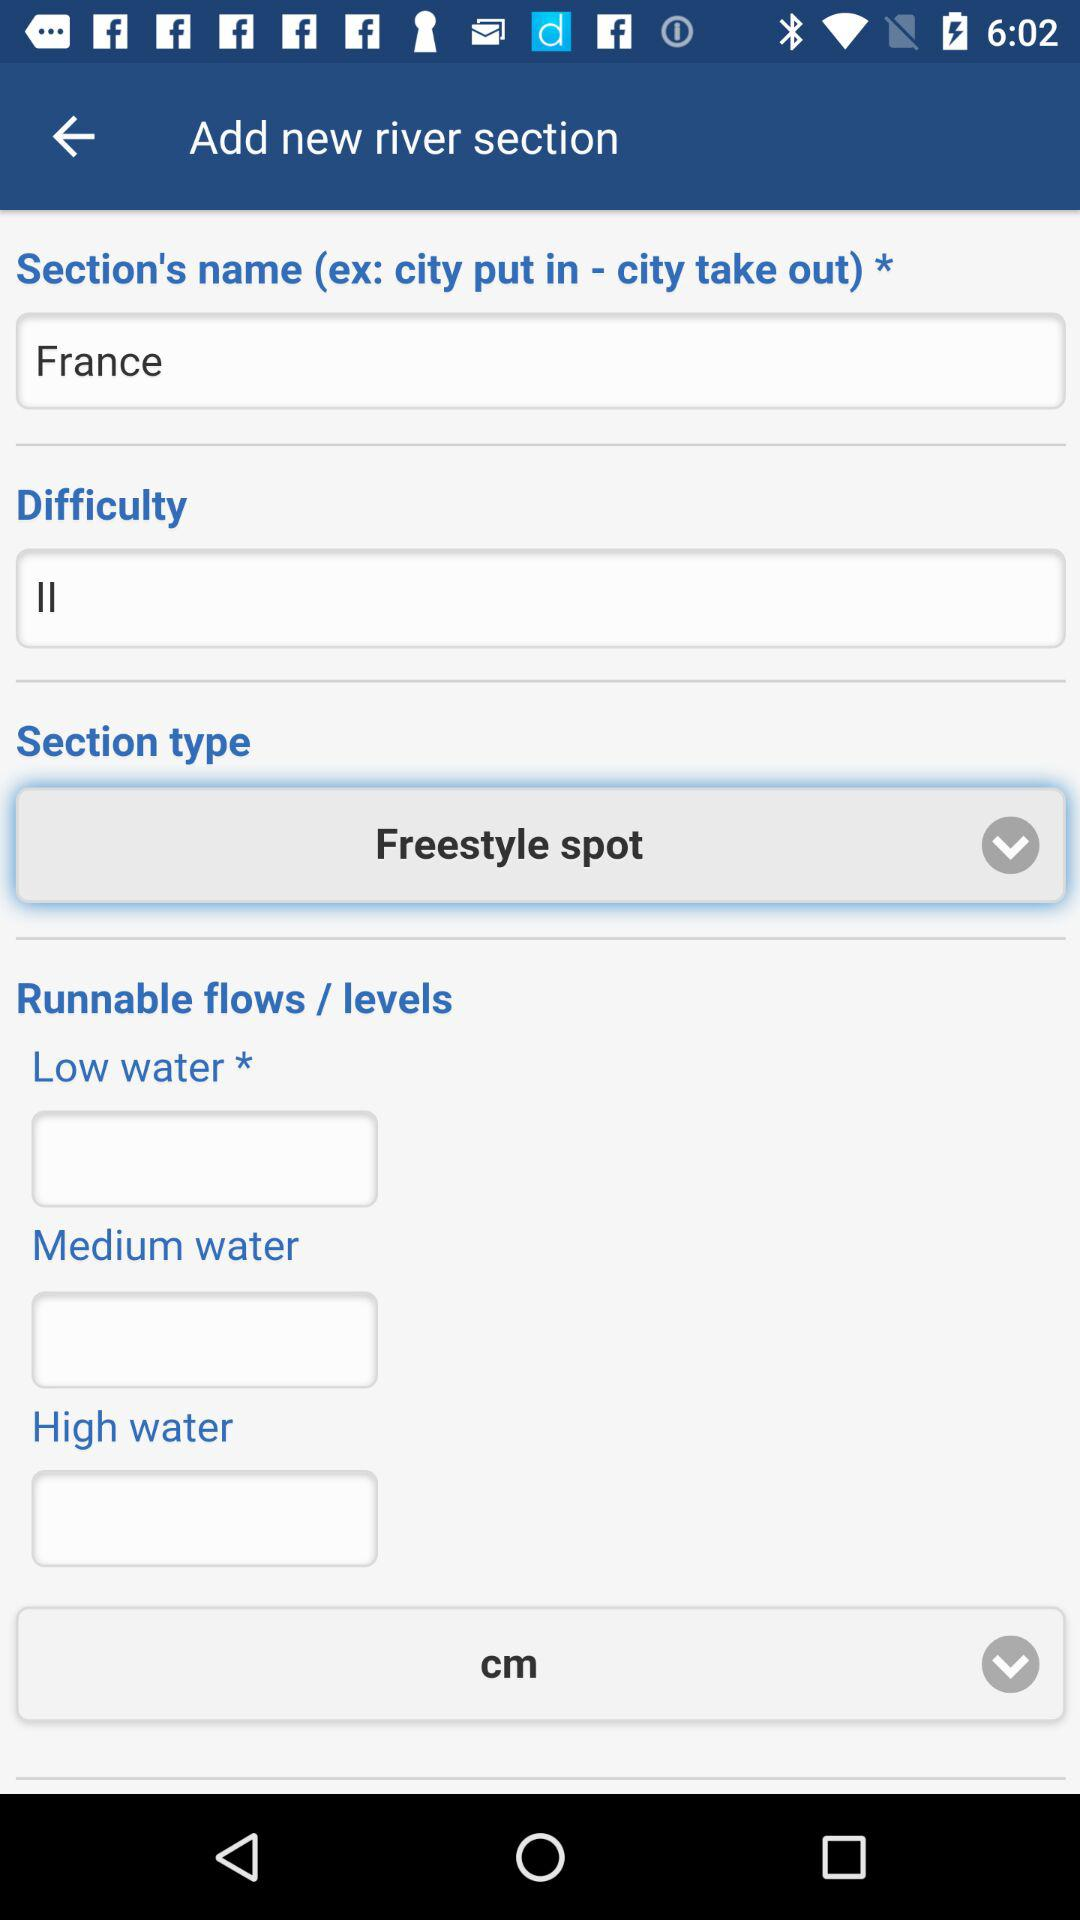Which is the selected "Section type"? The selected "Section type" is "Freestyle spot". 